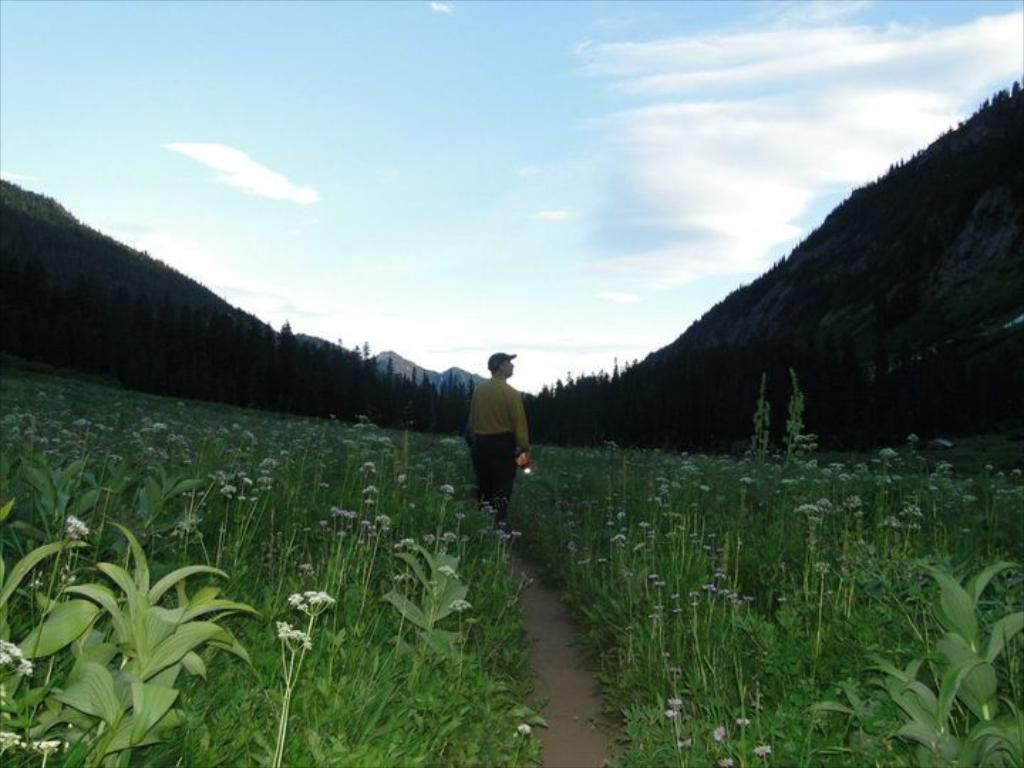What can be seen in the background of the image? There is sky in the image, as well as trees and plants. What is the primary subject of the image? There is a person standing in the image. What is the person holding in the image? The person is holding an object. How many crows are sitting on the person's shoulder in the image? There are no crows present in the image. What type of box is the person carrying in the image? There is no box visible in the image; the person is holding an unspecified object. 